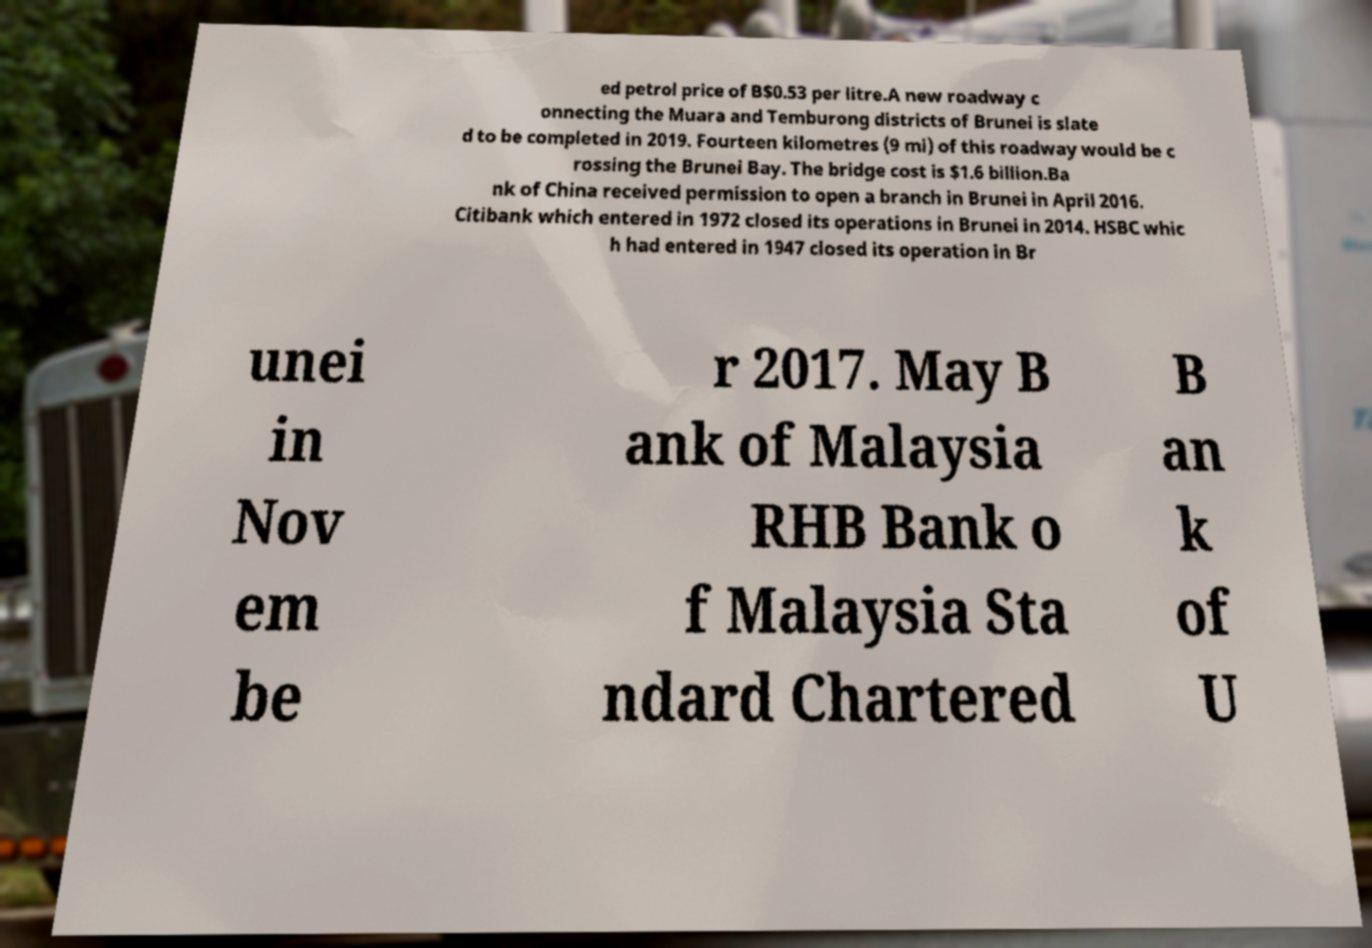Can you read and provide the text displayed in the image?This photo seems to have some interesting text. Can you extract and type it out for me? ed petrol price of B$0.53 per litre.A new roadway c onnecting the Muara and Temburong districts of Brunei is slate d to be completed in 2019. Fourteen kilometres (9 mi) of this roadway would be c rossing the Brunei Bay. The bridge cost is $1.6 billion.Ba nk of China received permission to open a branch in Brunei in April 2016. Citibank which entered in 1972 closed its operations in Brunei in 2014. HSBC whic h had entered in 1947 closed its operation in Br unei in Nov em be r 2017. May B ank of Malaysia RHB Bank o f Malaysia Sta ndard Chartered B an k of U 